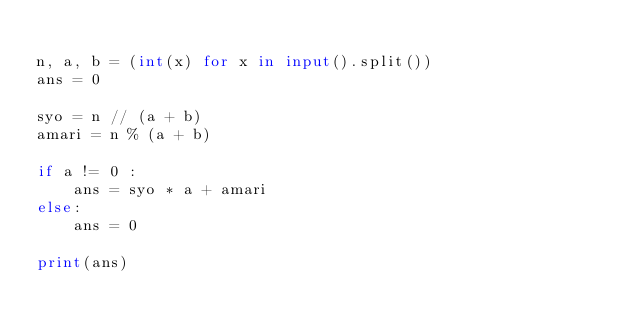Convert code to text. <code><loc_0><loc_0><loc_500><loc_500><_Python_>
n, a, b = (int(x) for x in input().split())
ans = 0

syo = n // (a + b)
amari = n % (a + b)

if a != 0 :
    ans = syo * a + amari
else:
    ans = 0

print(ans)

</code> 